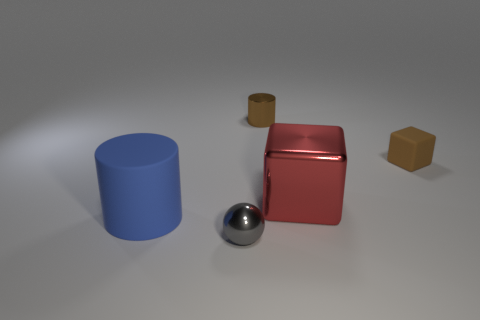Add 3 large red shiny things. How many objects exist? 8 Subtract all cubes. How many objects are left? 3 Add 3 big yellow balls. How many big yellow balls exist? 3 Subtract 0 cyan cylinders. How many objects are left? 5 Subtract all big blue matte cylinders. Subtract all big cubes. How many objects are left? 3 Add 3 tiny metal objects. How many tiny metal objects are left? 5 